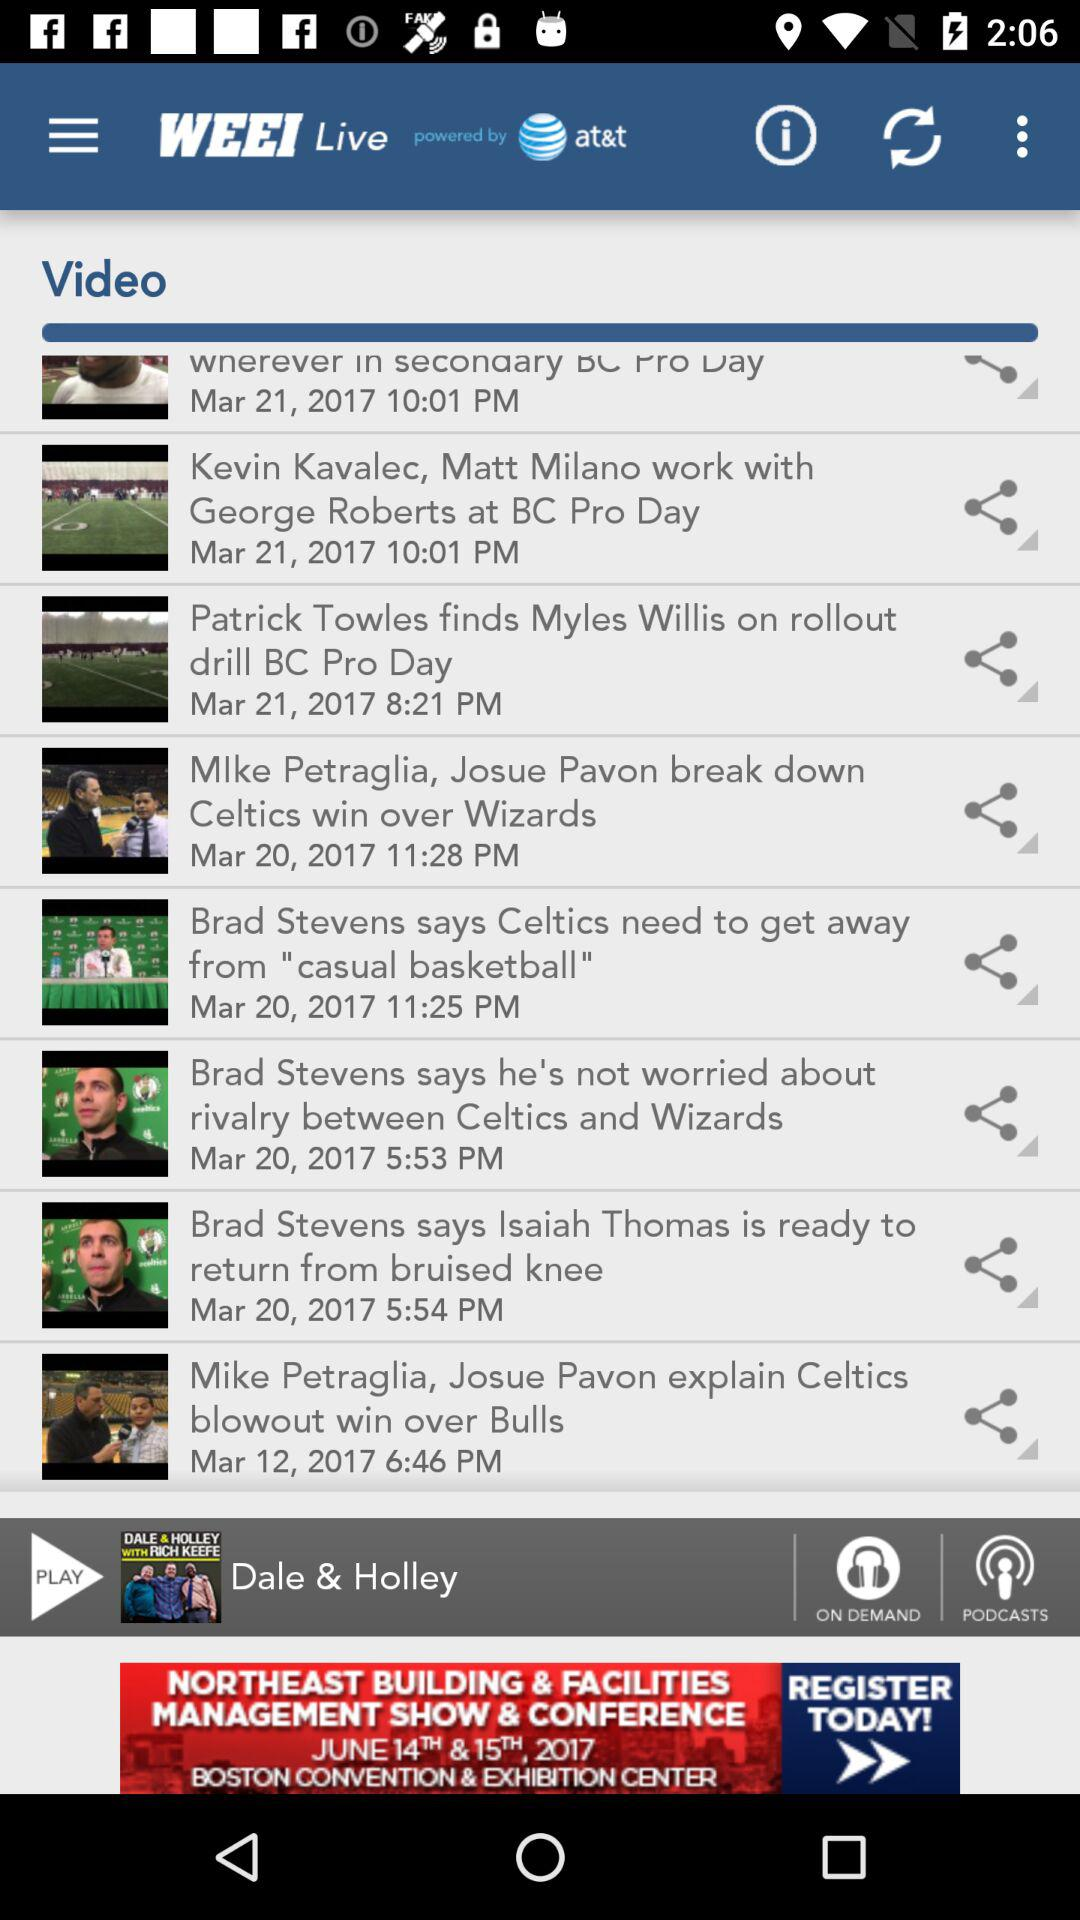How long is the "Dale & Holley" episode?
When the provided information is insufficient, respond with <no answer>. <no answer> 